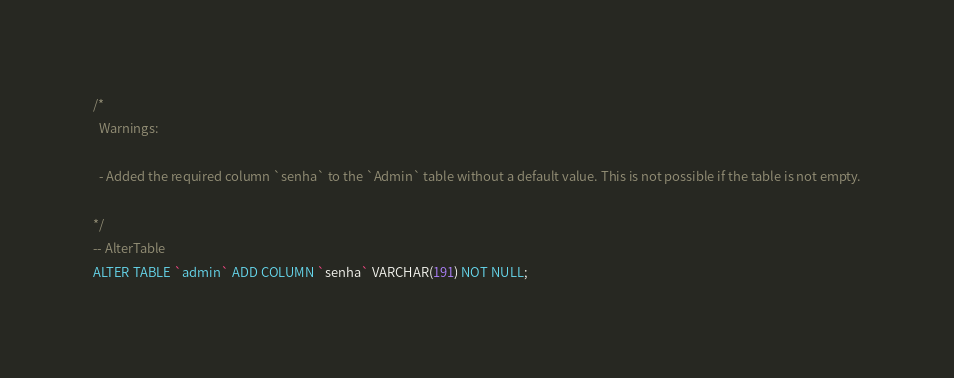Convert code to text. <code><loc_0><loc_0><loc_500><loc_500><_SQL_>/*
  Warnings:

  - Added the required column `senha` to the `Admin` table without a default value. This is not possible if the table is not empty.

*/
-- AlterTable
ALTER TABLE `admin` ADD COLUMN `senha` VARCHAR(191) NOT NULL;
</code> 